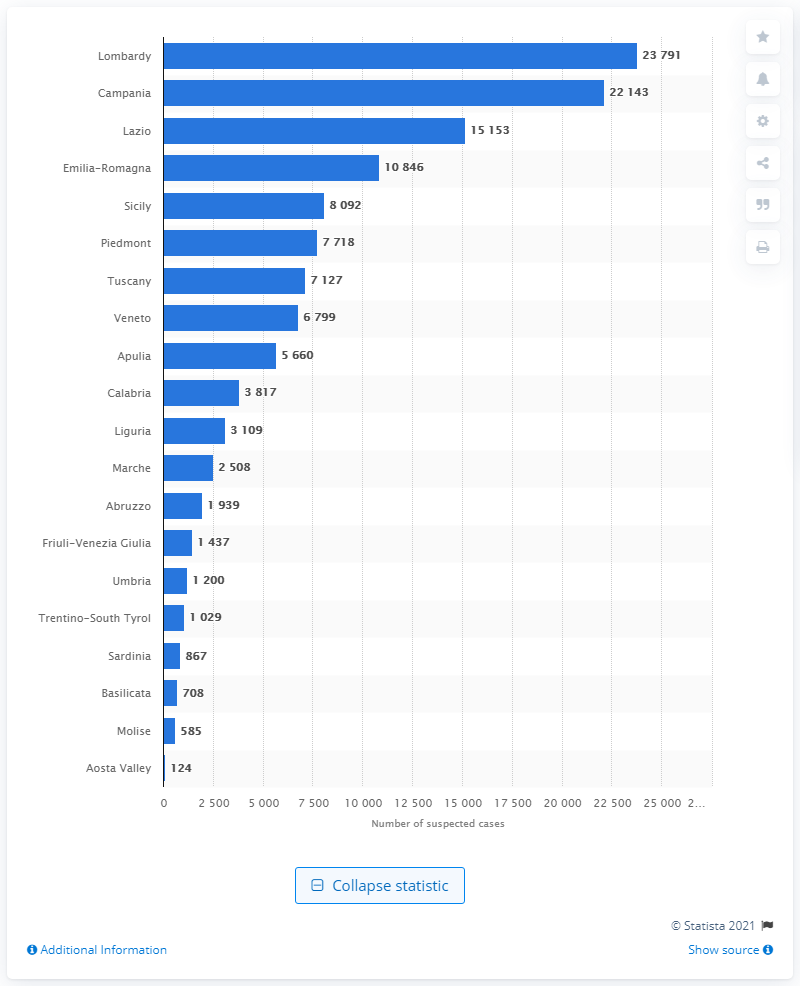Indicate a few pertinent items in this graphic. It is estimated that approximately 22.1 thousand suspected money laundering transactions occurred in the region of Campania. In 2019, the largest number of suspected financial operations was reported in the region of Lombardy in Italy. 